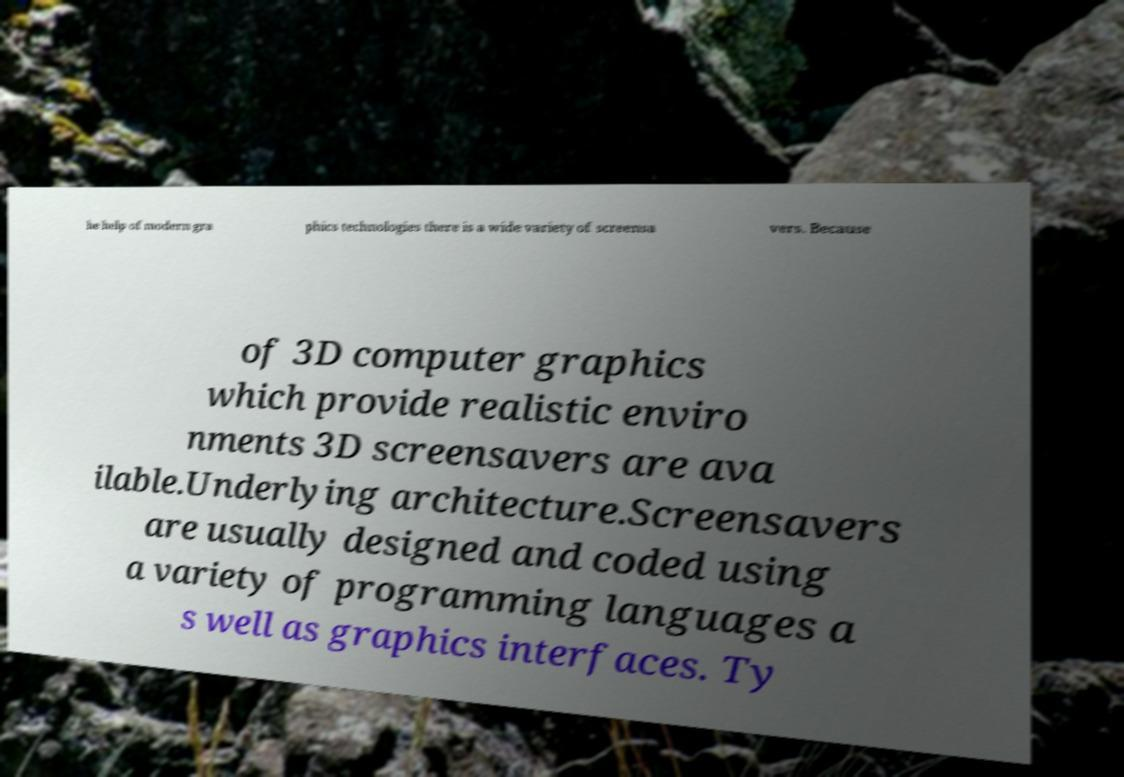Can you accurately transcribe the text from the provided image for me? he help of modern gra phics technologies there is a wide variety of screensa vers. Because of 3D computer graphics which provide realistic enviro nments 3D screensavers are ava ilable.Underlying architecture.Screensavers are usually designed and coded using a variety of programming languages a s well as graphics interfaces. Ty 